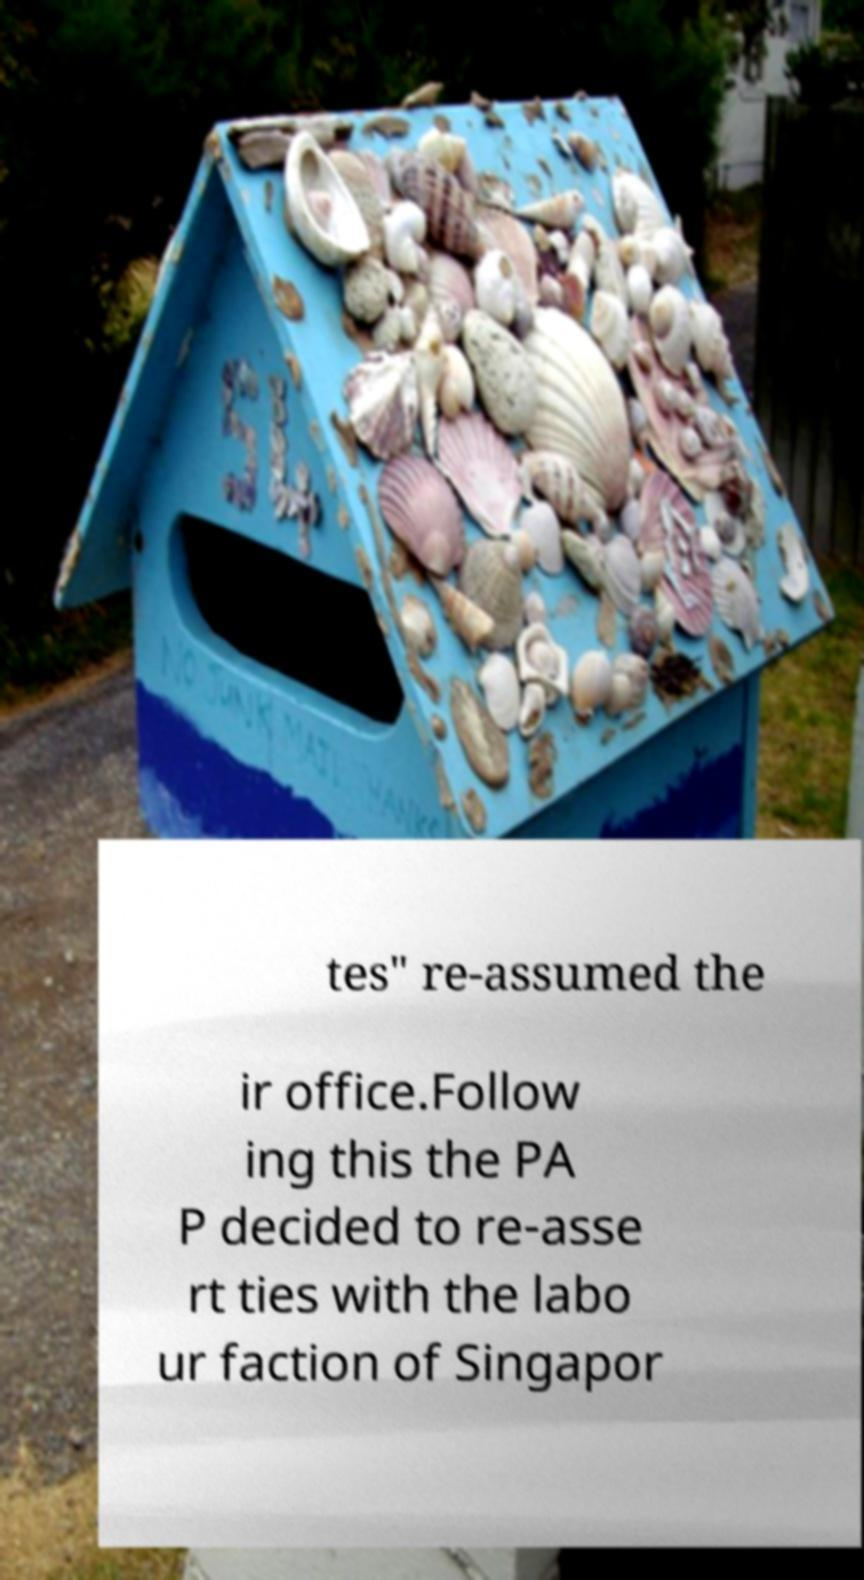Can you accurately transcribe the text from the provided image for me? tes" re-assumed the ir office.Follow ing this the PA P decided to re-asse rt ties with the labo ur faction of Singapor 